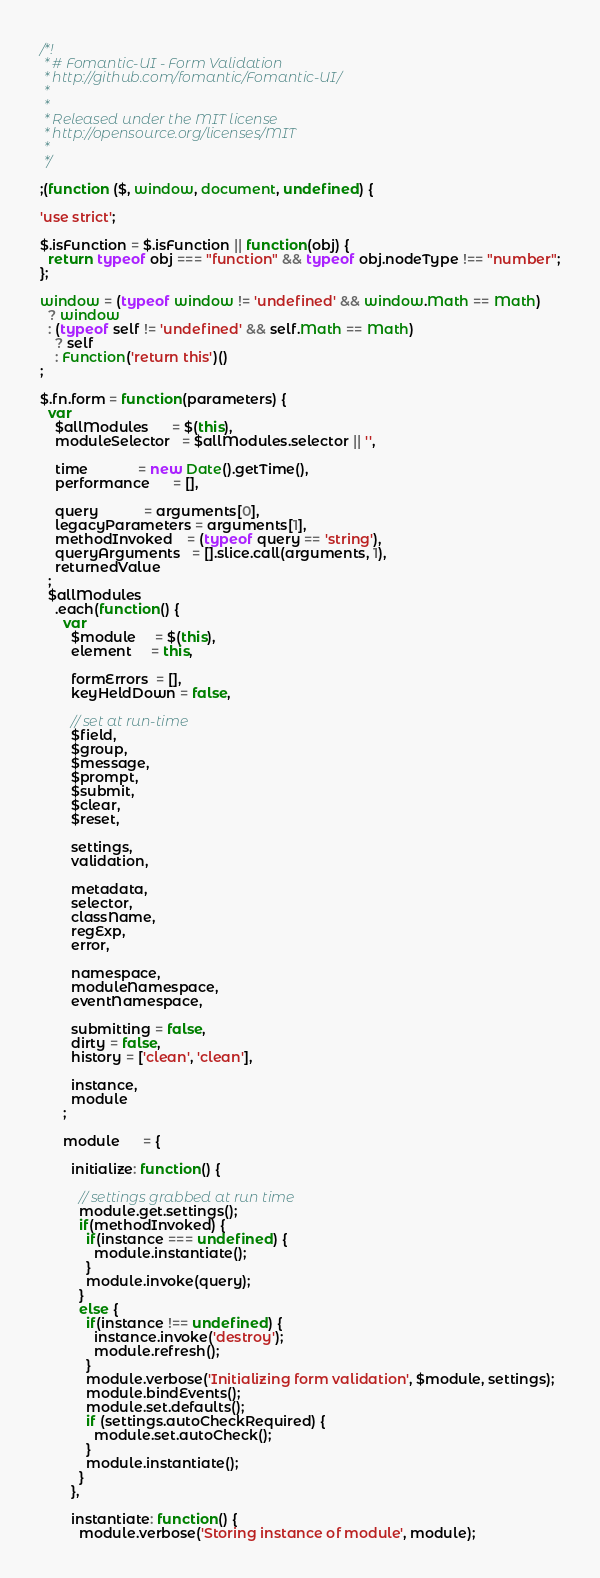<code> <loc_0><loc_0><loc_500><loc_500><_JavaScript_>/*!
 * # Fomantic-UI - Form Validation
 * http://github.com/fomantic/Fomantic-UI/
 *
 *
 * Released under the MIT license
 * http://opensource.org/licenses/MIT
 *
 */

;(function ($, window, document, undefined) {

'use strict';

$.isFunction = $.isFunction || function(obj) {
  return typeof obj === "function" && typeof obj.nodeType !== "number";
};

window = (typeof window != 'undefined' && window.Math == Math)
  ? window
  : (typeof self != 'undefined' && self.Math == Math)
    ? self
    : Function('return this')()
;

$.fn.form = function(parameters) {
  var
    $allModules      = $(this),
    moduleSelector   = $allModules.selector || '',

    time             = new Date().getTime(),
    performance      = [],

    query            = arguments[0],
    legacyParameters = arguments[1],
    methodInvoked    = (typeof query == 'string'),
    queryArguments   = [].slice.call(arguments, 1),
    returnedValue
  ;
  $allModules
    .each(function() {
      var
        $module     = $(this),
        element     = this,

        formErrors  = [],
        keyHeldDown = false,

        // set at run-time
        $field,
        $group,
        $message,
        $prompt,
        $submit,
        $clear,
        $reset,

        settings,
        validation,

        metadata,
        selector,
        className,
        regExp,
        error,

        namespace,
        moduleNamespace,
        eventNamespace,

        submitting = false,
        dirty = false,
        history = ['clean', 'clean'],

        instance,
        module
      ;

      module      = {

        initialize: function() {

          // settings grabbed at run time
          module.get.settings();
          if(methodInvoked) {
            if(instance === undefined) {
              module.instantiate();
            }
            module.invoke(query);
          }
          else {
            if(instance !== undefined) {
              instance.invoke('destroy');
              module.refresh();
            }
            module.verbose('Initializing form validation', $module, settings);
            module.bindEvents();
            module.set.defaults();
            if (settings.autoCheckRequired) {
              module.set.autoCheck();
            }
            module.instantiate();
          }
        },

        instantiate: function() {
          module.verbose('Storing instance of module', module);</code> 